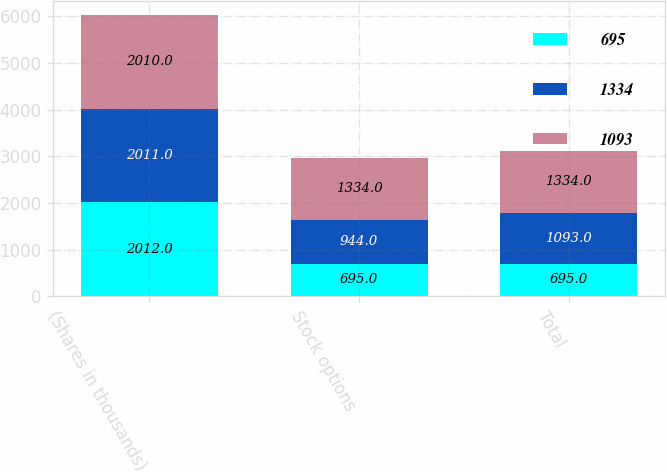<chart> <loc_0><loc_0><loc_500><loc_500><stacked_bar_chart><ecel><fcel>(Shares in thousands)<fcel>Stock options<fcel>Total<nl><fcel>695<fcel>2012<fcel>695<fcel>695<nl><fcel>1334<fcel>2011<fcel>944<fcel>1093<nl><fcel>1093<fcel>2010<fcel>1334<fcel>1334<nl></chart> 